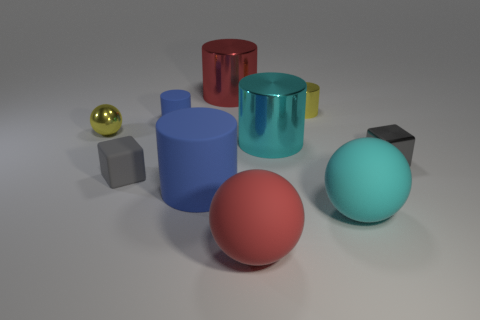Is there a small shiny cube of the same color as the tiny matte block?
Provide a short and direct response. Yes. The other matte cylinder that is the same color as the small rubber cylinder is what size?
Keep it short and to the point. Large. There is a small block that is left of the small blue matte thing; is its color the same as the small block that is on the right side of the large red cylinder?
Make the answer very short. Yes. The other matte object that is the same shape as the cyan rubber thing is what color?
Your response must be concise. Red. Is the number of large things greater than the number of tiny brown spheres?
Keep it short and to the point. Yes. Does the small sphere have the same material as the yellow cylinder?
Your answer should be compact. Yes. How many other spheres have the same material as the cyan ball?
Ensure brevity in your answer.  1. Does the red matte thing have the same size as the cyan cylinder that is behind the red matte ball?
Give a very brief answer. Yes. What is the color of the large object that is both in front of the tiny gray metallic block and behind the big cyan rubber object?
Provide a succinct answer. Blue. Are there any yellow shiny spheres left of the small block in front of the tiny shiny cube?
Offer a terse response. Yes. 